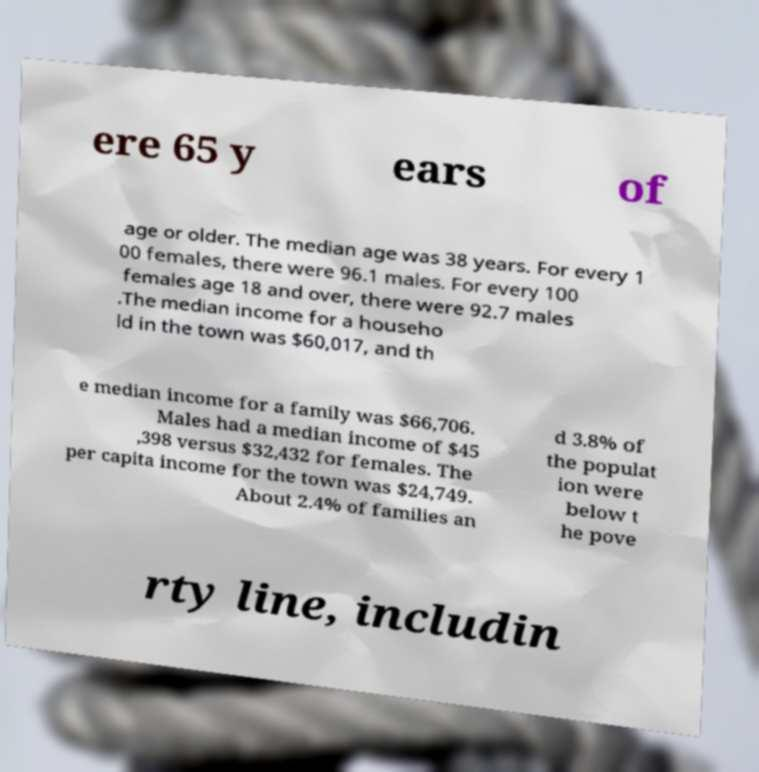Please read and relay the text visible in this image. What does it say? ere 65 y ears of age or older. The median age was 38 years. For every 1 00 females, there were 96.1 males. For every 100 females age 18 and over, there were 92.7 males .The median income for a househo ld in the town was $60,017, and th e median income for a family was $66,706. Males had a median income of $45 ,398 versus $32,432 for females. The per capita income for the town was $24,749. About 2.4% of families an d 3.8% of the populat ion were below t he pove rty line, includin 